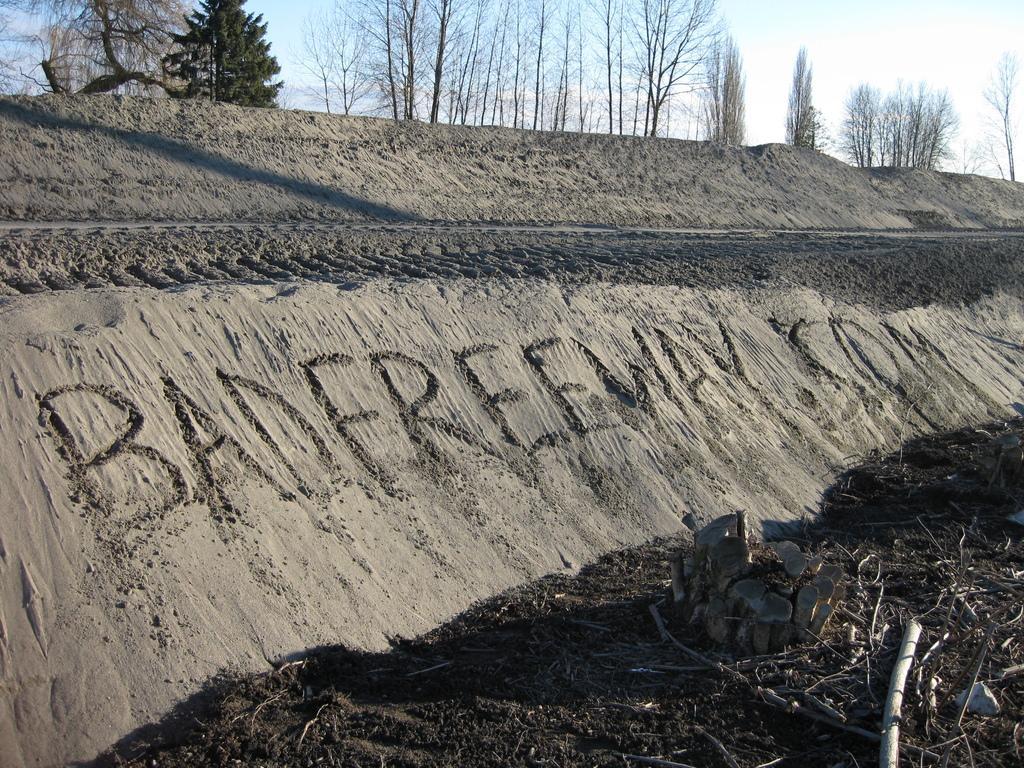What type of vegetation is visible at the top side of the image? There are trees at the top side of the image. What type of terrain is present at the bottom side of the image? There is mud at the bottom side of the image. What type of cloud can be seen floating in the mud at the bottom side of the image? There is no cloud present in the image, and the mud is not depicted as floating. 